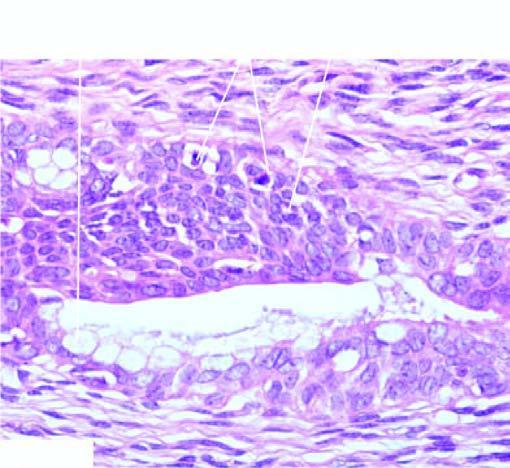have layers of squamous epithelium marked cytologic atypia including mitoses?
Answer the question using a single word or phrase. Yes 